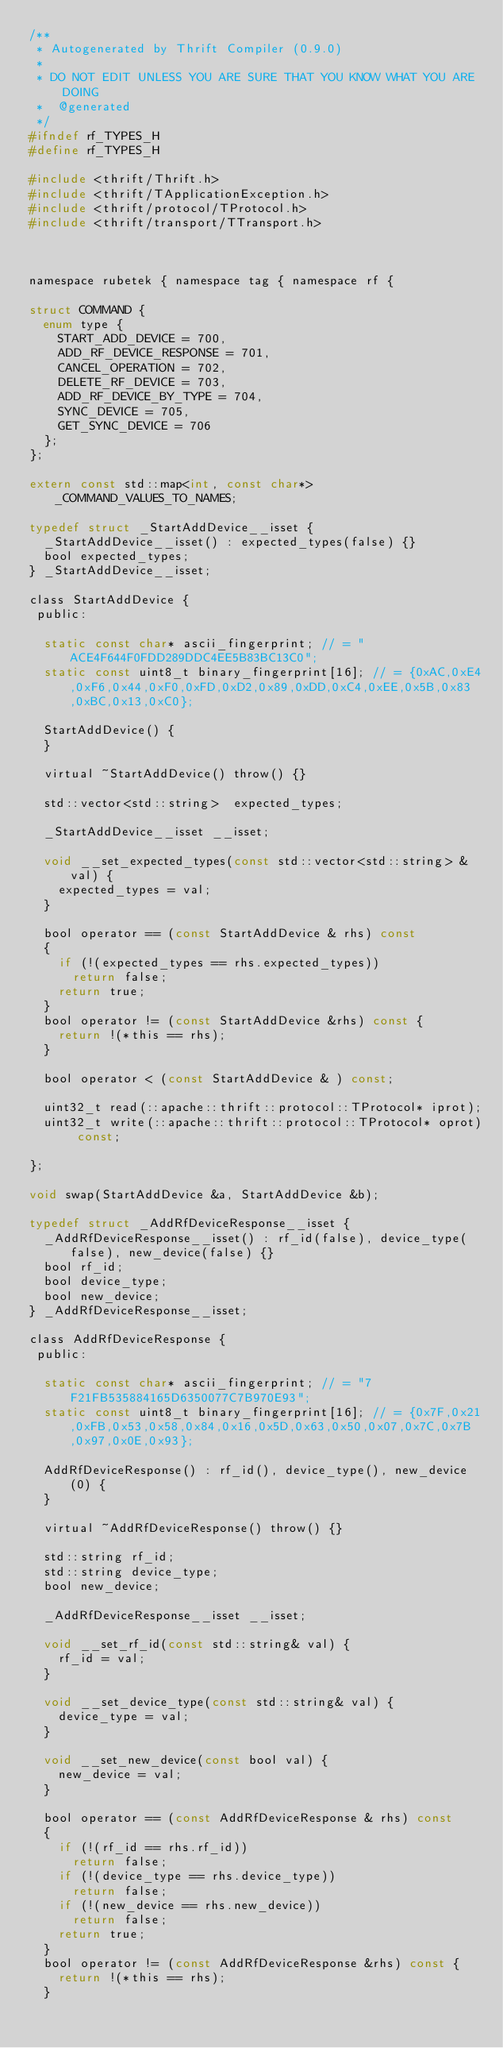Convert code to text. <code><loc_0><loc_0><loc_500><loc_500><_C_>/**
 * Autogenerated by Thrift Compiler (0.9.0)
 *
 * DO NOT EDIT UNLESS YOU ARE SURE THAT YOU KNOW WHAT YOU ARE DOING
 *  @generated
 */
#ifndef rf_TYPES_H
#define rf_TYPES_H

#include <thrift/Thrift.h>
#include <thrift/TApplicationException.h>
#include <thrift/protocol/TProtocol.h>
#include <thrift/transport/TTransport.h>



namespace rubetek { namespace tag { namespace rf {

struct COMMAND {
  enum type {
    START_ADD_DEVICE = 700,
    ADD_RF_DEVICE_RESPONSE = 701,
    CANCEL_OPERATION = 702,
    DELETE_RF_DEVICE = 703,
    ADD_RF_DEVICE_BY_TYPE = 704,
    SYNC_DEVICE = 705,
    GET_SYNC_DEVICE = 706
  };
};

extern const std::map<int, const char*> _COMMAND_VALUES_TO_NAMES;

typedef struct _StartAddDevice__isset {
  _StartAddDevice__isset() : expected_types(false) {}
  bool expected_types;
} _StartAddDevice__isset;

class StartAddDevice {
 public:

  static const char* ascii_fingerprint; // = "ACE4F644F0FDD289DDC4EE5B83BC13C0";
  static const uint8_t binary_fingerprint[16]; // = {0xAC,0xE4,0xF6,0x44,0xF0,0xFD,0xD2,0x89,0xDD,0xC4,0xEE,0x5B,0x83,0xBC,0x13,0xC0};

  StartAddDevice() {
  }

  virtual ~StartAddDevice() throw() {}

  std::vector<std::string>  expected_types;

  _StartAddDevice__isset __isset;

  void __set_expected_types(const std::vector<std::string> & val) {
    expected_types = val;
  }

  bool operator == (const StartAddDevice & rhs) const
  {
    if (!(expected_types == rhs.expected_types))
      return false;
    return true;
  }
  bool operator != (const StartAddDevice &rhs) const {
    return !(*this == rhs);
  }

  bool operator < (const StartAddDevice & ) const;

  uint32_t read(::apache::thrift::protocol::TProtocol* iprot);
  uint32_t write(::apache::thrift::protocol::TProtocol* oprot) const;

};

void swap(StartAddDevice &a, StartAddDevice &b);

typedef struct _AddRfDeviceResponse__isset {
  _AddRfDeviceResponse__isset() : rf_id(false), device_type(false), new_device(false) {}
  bool rf_id;
  bool device_type;
  bool new_device;
} _AddRfDeviceResponse__isset;

class AddRfDeviceResponse {
 public:

  static const char* ascii_fingerprint; // = "7F21FB535884165D6350077C7B970E93";
  static const uint8_t binary_fingerprint[16]; // = {0x7F,0x21,0xFB,0x53,0x58,0x84,0x16,0x5D,0x63,0x50,0x07,0x7C,0x7B,0x97,0x0E,0x93};

  AddRfDeviceResponse() : rf_id(), device_type(), new_device(0) {
  }

  virtual ~AddRfDeviceResponse() throw() {}

  std::string rf_id;
  std::string device_type;
  bool new_device;

  _AddRfDeviceResponse__isset __isset;

  void __set_rf_id(const std::string& val) {
    rf_id = val;
  }

  void __set_device_type(const std::string& val) {
    device_type = val;
  }

  void __set_new_device(const bool val) {
    new_device = val;
  }

  bool operator == (const AddRfDeviceResponse & rhs) const
  {
    if (!(rf_id == rhs.rf_id))
      return false;
    if (!(device_type == rhs.device_type))
      return false;
    if (!(new_device == rhs.new_device))
      return false;
    return true;
  }
  bool operator != (const AddRfDeviceResponse &rhs) const {
    return !(*this == rhs);
  }
</code> 